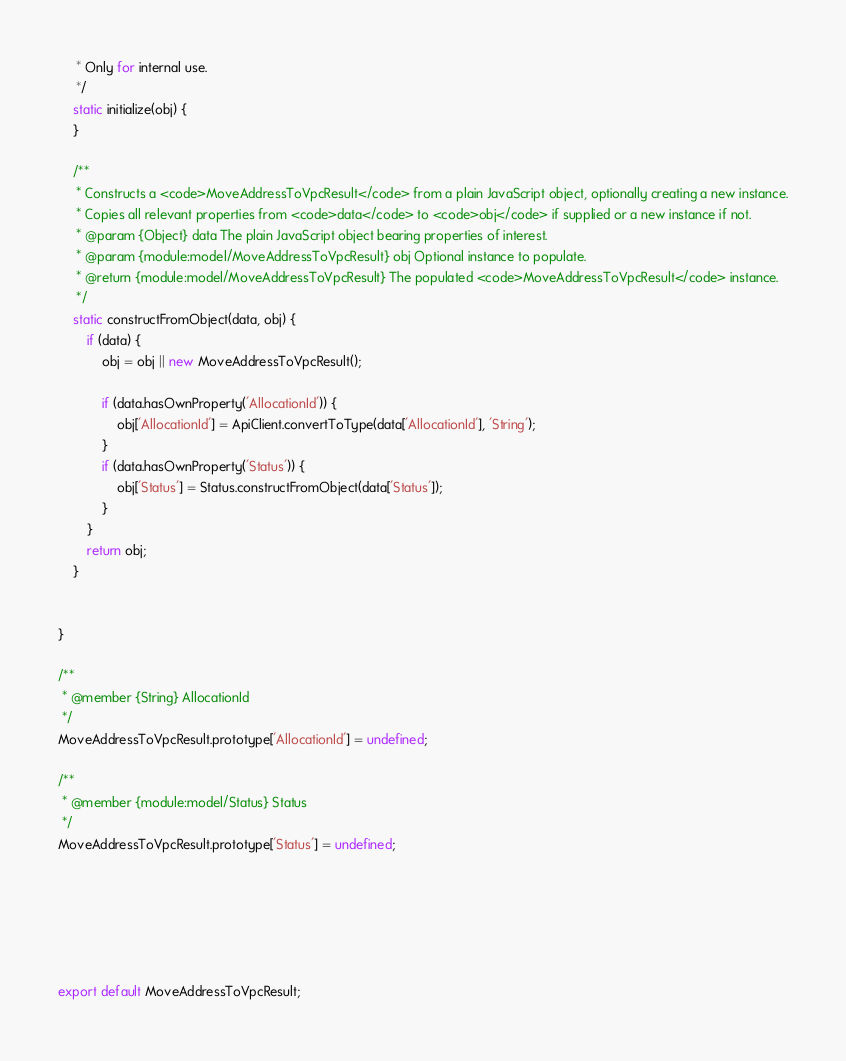<code> <loc_0><loc_0><loc_500><loc_500><_JavaScript_>     * Only for internal use.
     */
    static initialize(obj) { 
    }

    /**
     * Constructs a <code>MoveAddressToVpcResult</code> from a plain JavaScript object, optionally creating a new instance.
     * Copies all relevant properties from <code>data</code> to <code>obj</code> if supplied or a new instance if not.
     * @param {Object} data The plain JavaScript object bearing properties of interest.
     * @param {module:model/MoveAddressToVpcResult} obj Optional instance to populate.
     * @return {module:model/MoveAddressToVpcResult} The populated <code>MoveAddressToVpcResult</code> instance.
     */
    static constructFromObject(data, obj) {
        if (data) {
            obj = obj || new MoveAddressToVpcResult();

            if (data.hasOwnProperty('AllocationId')) {
                obj['AllocationId'] = ApiClient.convertToType(data['AllocationId'], 'String');
            }
            if (data.hasOwnProperty('Status')) {
                obj['Status'] = Status.constructFromObject(data['Status']);
            }
        }
        return obj;
    }


}

/**
 * @member {String} AllocationId
 */
MoveAddressToVpcResult.prototype['AllocationId'] = undefined;

/**
 * @member {module:model/Status} Status
 */
MoveAddressToVpcResult.prototype['Status'] = undefined;






export default MoveAddressToVpcResult;

</code> 